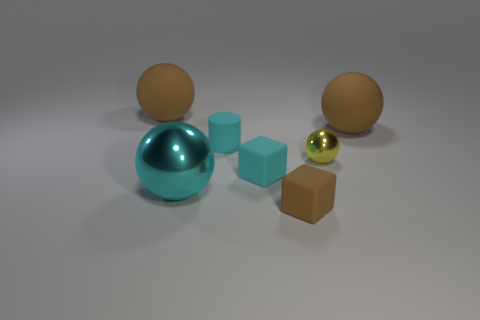What is the size of the metal object that is the same color as the cylinder?
Offer a very short reply. Large. Are there any cyan cubes to the right of the large cyan metal object?
Keep it short and to the point. Yes. Are there more small rubber things that are behind the small yellow metal sphere than small purple metallic blocks?
Your response must be concise. Yes. Is there a thing of the same color as the cylinder?
Offer a terse response. Yes. What color is the matte cylinder that is the same size as the yellow metallic thing?
Your answer should be compact. Cyan. Is there a yellow object that is on the left side of the big brown matte thing on the right side of the tiny metal object?
Keep it short and to the point. Yes. There is a big brown object that is right of the brown block; what material is it?
Ensure brevity in your answer.  Rubber. Is the big sphere that is right of the rubber cylinder made of the same material as the brown ball to the left of the tiny brown cube?
Keep it short and to the point. Yes. Are there an equal number of brown matte balls behind the tiny brown matte block and blocks right of the yellow object?
Your response must be concise. No. How many large brown spheres have the same material as the tiny brown object?
Your response must be concise. 2. 